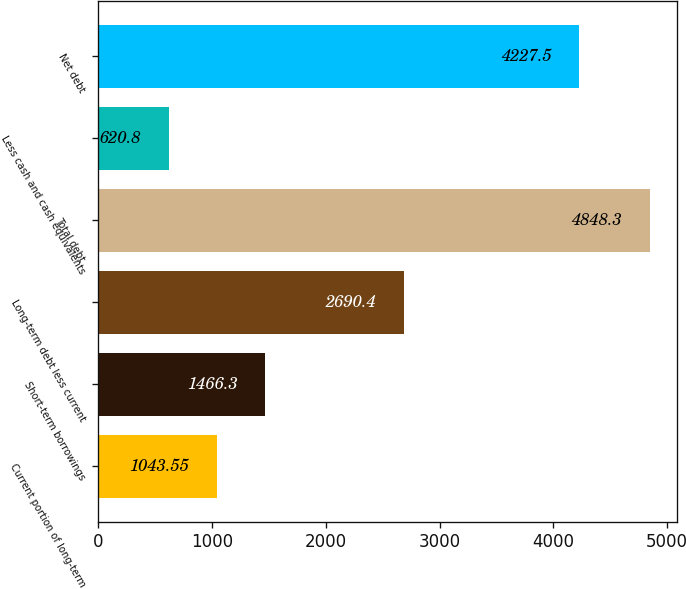Convert chart to OTSL. <chart><loc_0><loc_0><loc_500><loc_500><bar_chart><fcel>Current portion of long-term<fcel>Short-term borrowings<fcel>Long-term debt less current<fcel>Total debt<fcel>Less cash and cash equivalents<fcel>Net debt<nl><fcel>1043.55<fcel>1466.3<fcel>2690.4<fcel>4848.3<fcel>620.8<fcel>4227.5<nl></chart> 